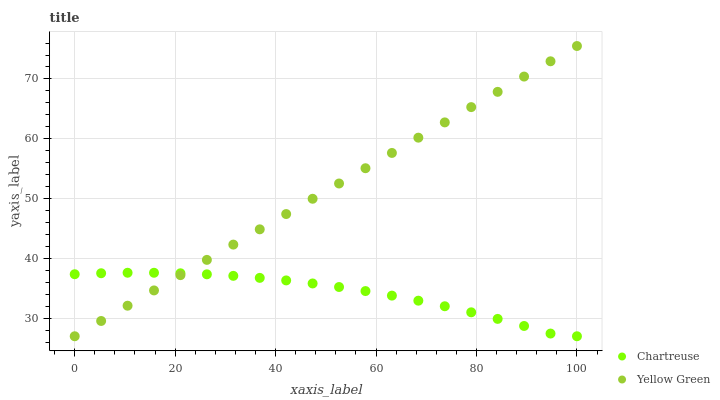Does Chartreuse have the minimum area under the curve?
Answer yes or no. Yes. Does Yellow Green have the maximum area under the curve?
Answer yes or no. Yes. Does Yellow Green have the minimum area under the curve?
Answer yes or no. No. Is Yellow Green the smoothest?
Answer yes or no. Yes. Is Chartreuse the roughest?
Answer yes or no. Yes. Is Yellow Green the roughest?
Answer yes or no. No. Does Chartreuse have the lowest value?
Answer yes or no. Yes. Does Yellow Green have the highest value?
Answer yes or no. Yes. Does Yellow Green intersect Chartreuse?
Answer yes or no. Yes. Is Yellow Green less than Chartreuse?
Answer yes or no. No. Is Yellow Green greater than Chartreuse?
Answer yes or no. No. 